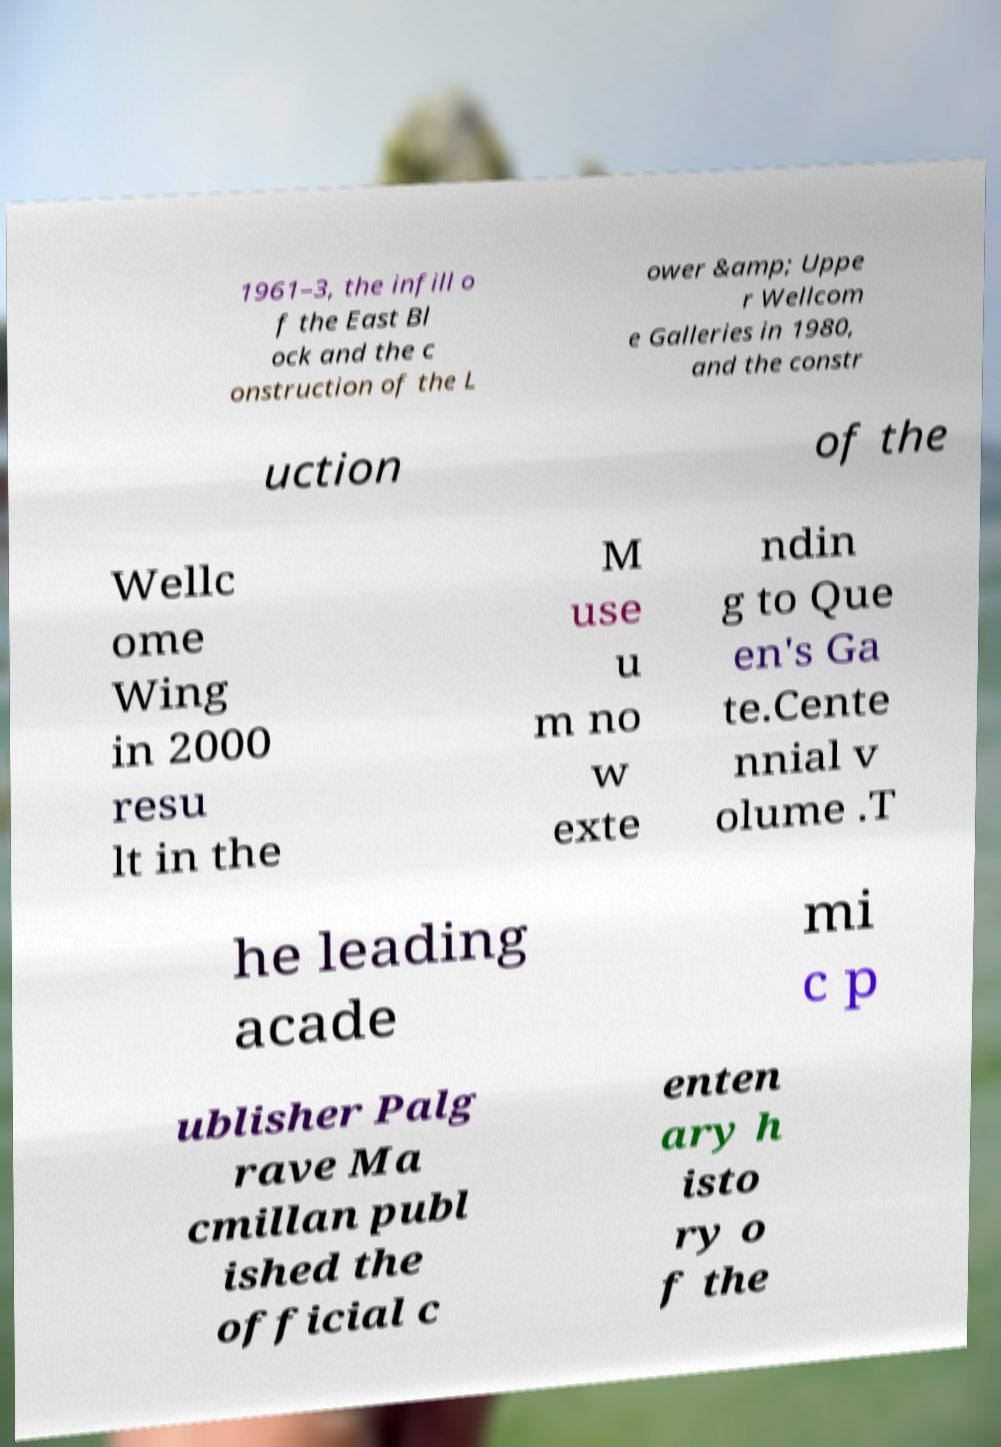What messages or text are displayed in this image? I need them in a readable, typed format. 1961–3, the infill o f the East Bl ock and the c onstruction of the L ower &amp; Uppe r Wellcom e Galleries in 1980, and the constr uction of the Wellc ome Wing in 2000 resu lt in the M use u m no w exte ndin g to Que en's Ga te.Cente nnial v olume .T he leading acade mi c p ublisher Palg rave Ma cmillan publ ished the official c enten ary h isto ry o f the 